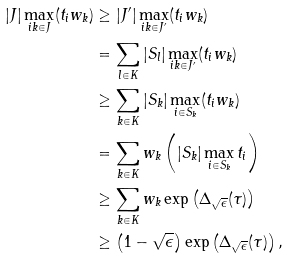<formula> <loc_0><loc_0><loc_500><loc_500>| J | \max _ { i k \in J } ( t _ { i } w _ { k } ) & \geq | J ^ { \prime } | \max _ { i k \in J ^ { \prime } } ( t _ { i } w _ { k } ) \\ & = \sum _ { l \in K } | S _ { l } | \max _ { i k \in J ^ { \prime } } ( t _ { i } w _ { k } ) \\ & \geq \sum _ { k \in K } | S _ { k } | \max _ { i \in S _ { k } } ( t _ { i } w _ { k } ) \\ & = \sum _ { k \in K } w _ { k } \left ( | S _ { k } | \max _ { i \in S _ { k } } t _ { i } \right ) \\ & \geq \sum _ { k \in K } w _ { k } \exp \left ( \Delta _ { \sqrt { \epsilon } } ( \tau ) \right ) \\ & \geq \left ( 1 - \sqrt { \epsilon } \right ) \exp \left ( \Delta _ { \sqrt { \epsilon } } ( \tau ) \right ) ,</formula> 